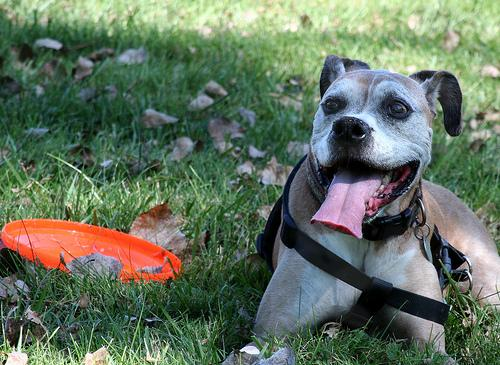What is the color of the dog's nose? The dog's nose is black. What is the predominant feature on the dog's face? Gray fur covers the dog's face. Count the number of dog eyes visible in the image. There are two dog eyes visible. Which time of day does the image seem to be taken? The image appears to be taken during the day. What color is the frisbee in the image? The frisbee is orange. What kind of objects are lying on the grass in the image? Dried leaves and a frisbee are on the grass. Mention an action performed by the dog in the picture. The dog is sticking out its tongue. Is the dog standing, sitting, or laying down in the picture? The dog is laying down on the grass. What kind of object is on the dog's collar? There are tags on the dog's collar. Provide a brief description of the objects around the dog in the image. There are brown leaves and an orange frisbee on the grass near the dog. 